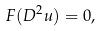Convert formula to latex. <formula><loc_0><loc_0><loc_500><loc_500>F ( D ^ { 2 } u ) = 0 ,</formula> 